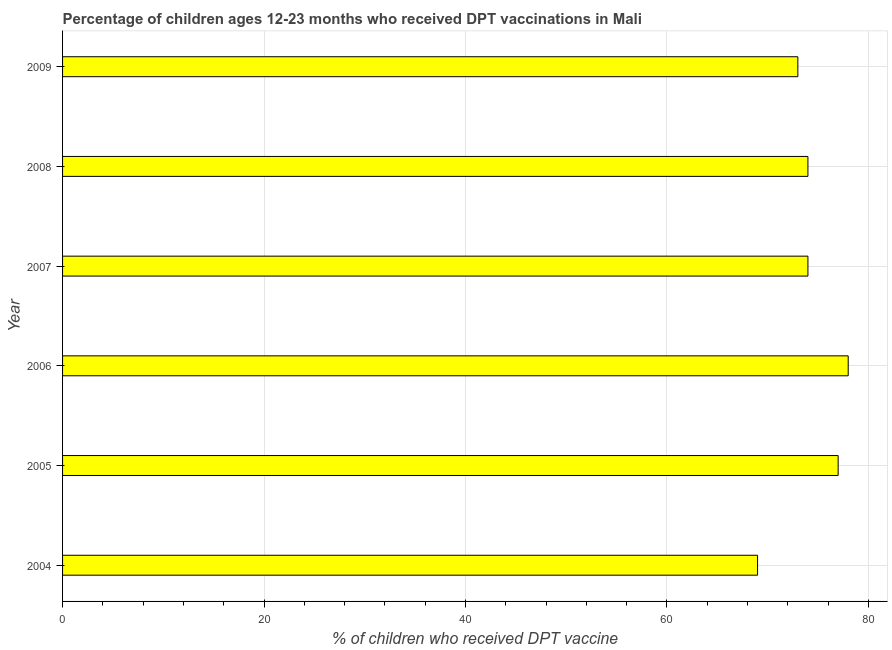Does the graph contain grids?
Keep it short and to the point. Yes. What is the title of the graph?
Ensure brevity in your answer.  Percentage of children ages 12-23 months who received DPT vaccinations in Mali. What is the label or title of the X-axis?
Make the answer very short. % of children who received DPT vaccine. What is the percentage of children who received dpt vaccine in 2006?
Keep it short and to the point. 78. In which year was the percentage of children who received dpt vaccine minimum?
Keep it short and to the point. 2004. What is the sum of the percentage of children who received dpt vaccine?
Offer a terse response. 445. What is the average percentage of children who received dpt vaccine per year?
Make the answer very short. 74. What is the ratio of the percentage of children who received dpt vaccine in 2005 to that in 2007?
Make the answer very short. 1.04. Is the percentage of children who received dpt vaccine in 2005 less than that in 2006?
Ensure brevity in your answer.  Yes. Is the sum of the percentage of children who received dpt vaccine in 2007 and 2008 greater than the maximum percentage of children who received dpt vaccine across all years?
Offer a very short reply. Yes. What is the difference between the highest and the lowest percentage of children who received dpt vaccine?
Offer a terse response. 9. How many bars are there?
Ensure brevity in your answer.  6. Are all the bars in the graph horizontal?
Offer a terse response. Yes. How many years are there in the graph?
Ensure brevity in your answer.  6. Are the values on the major ticks of X-axis written in scientific E-notation?
Give a very brief answer. No. What is the % of children who received DPT vaccine of 2004?
Give a very brief answer. 69. What is the % of children who received DPT vaccine in 2006?
Your answer should be compact. 78. What is the % of children who received DPT vaccine of 2007?
Provide a succinct answer. 74. What is the % of children who received DPT vaccine in 2008?
Offer a very short reply. 74. What is the % of children who received DPT vaccine in 2009?
Give a very brief answer. 73. What is the difference between the % of children who received DPT vaccine in 2004 and 2009?
Ensure brevity in your answer.  -4. What is the difference between the % of children who received DPT vaccine in 2005 and 2007?
Provide a short and direct response. 3. What is the difference between the % of children who received DPT vaccine in 2005 and 2008?
Your answer should be very brief. 3. What is the difference between the % of children who received DPT vaccine in 2005 and 2009?
Ensure brevity in your answer.  4. What is the difference between the % of children who received DPT vaccine in 2006 and 2007?
Give a very brief answer. 4. What is the difference between the % of children who received DPT vaccine in 2006 and 2009?
Keep it short and to the point. 5. What is the difference between the % of children who received DPT vaccine in 2007 and 2008?
Make the answer very short. 0. What is the difference between the % of children who received DPT vaccine in 2007 and 2009?
Your response must be concise. 1. What is the ratio of the % of children who received DPT vaccine in 2004 to that in 2005?
Your answer should be very brief. 0.9. What is the ratio of the % of children who received DPT vaccine in 2004 to that in 2006?
Your answer should be compact. 0.89. What is the ratio of the % of children who received DPT vaccine in 2004 to that in 2007?
Your answer should be very brief. 0.93. What is the ratio of the % of children who received DPT vaccine in 2004 to that in 2008?
Give a very brief answer. 0.93. What is the ratio of the % of children who received DPT vaccine in 2004 to that in 2009?
Your answer should be very brief. 0.94. What is the ratio of the % of children who received DPT vaccine in 2005 to that in 2007?
Provide a short and direct response. 1.04. What is the ratio of the % of children who received DPT vaccine in 2005 to that in 2008?
Offer a very short reply. 1.04. What is the ratio of the % of children who received DPT vaccine in 2005 to that in 2009?
Give a very brief answer. 1.05. What is the ratio of the % of children who received DPT vaccine in 2006 to that in 2007?
Offer a terse response. 1.05. What is the ratio of the % of children who received DPT vaccine in 2006 to that in 2008?
Make the answer very short. 1.05. What is the ratio of the % of children who received DPT vaccine in 2006 to that in 2009?
Keep it short and to the point. 1.07. What is the ratio of the % of children who received DPT vaccine in 2007 to that in 2008?
Provide a short and direct response. 1. 